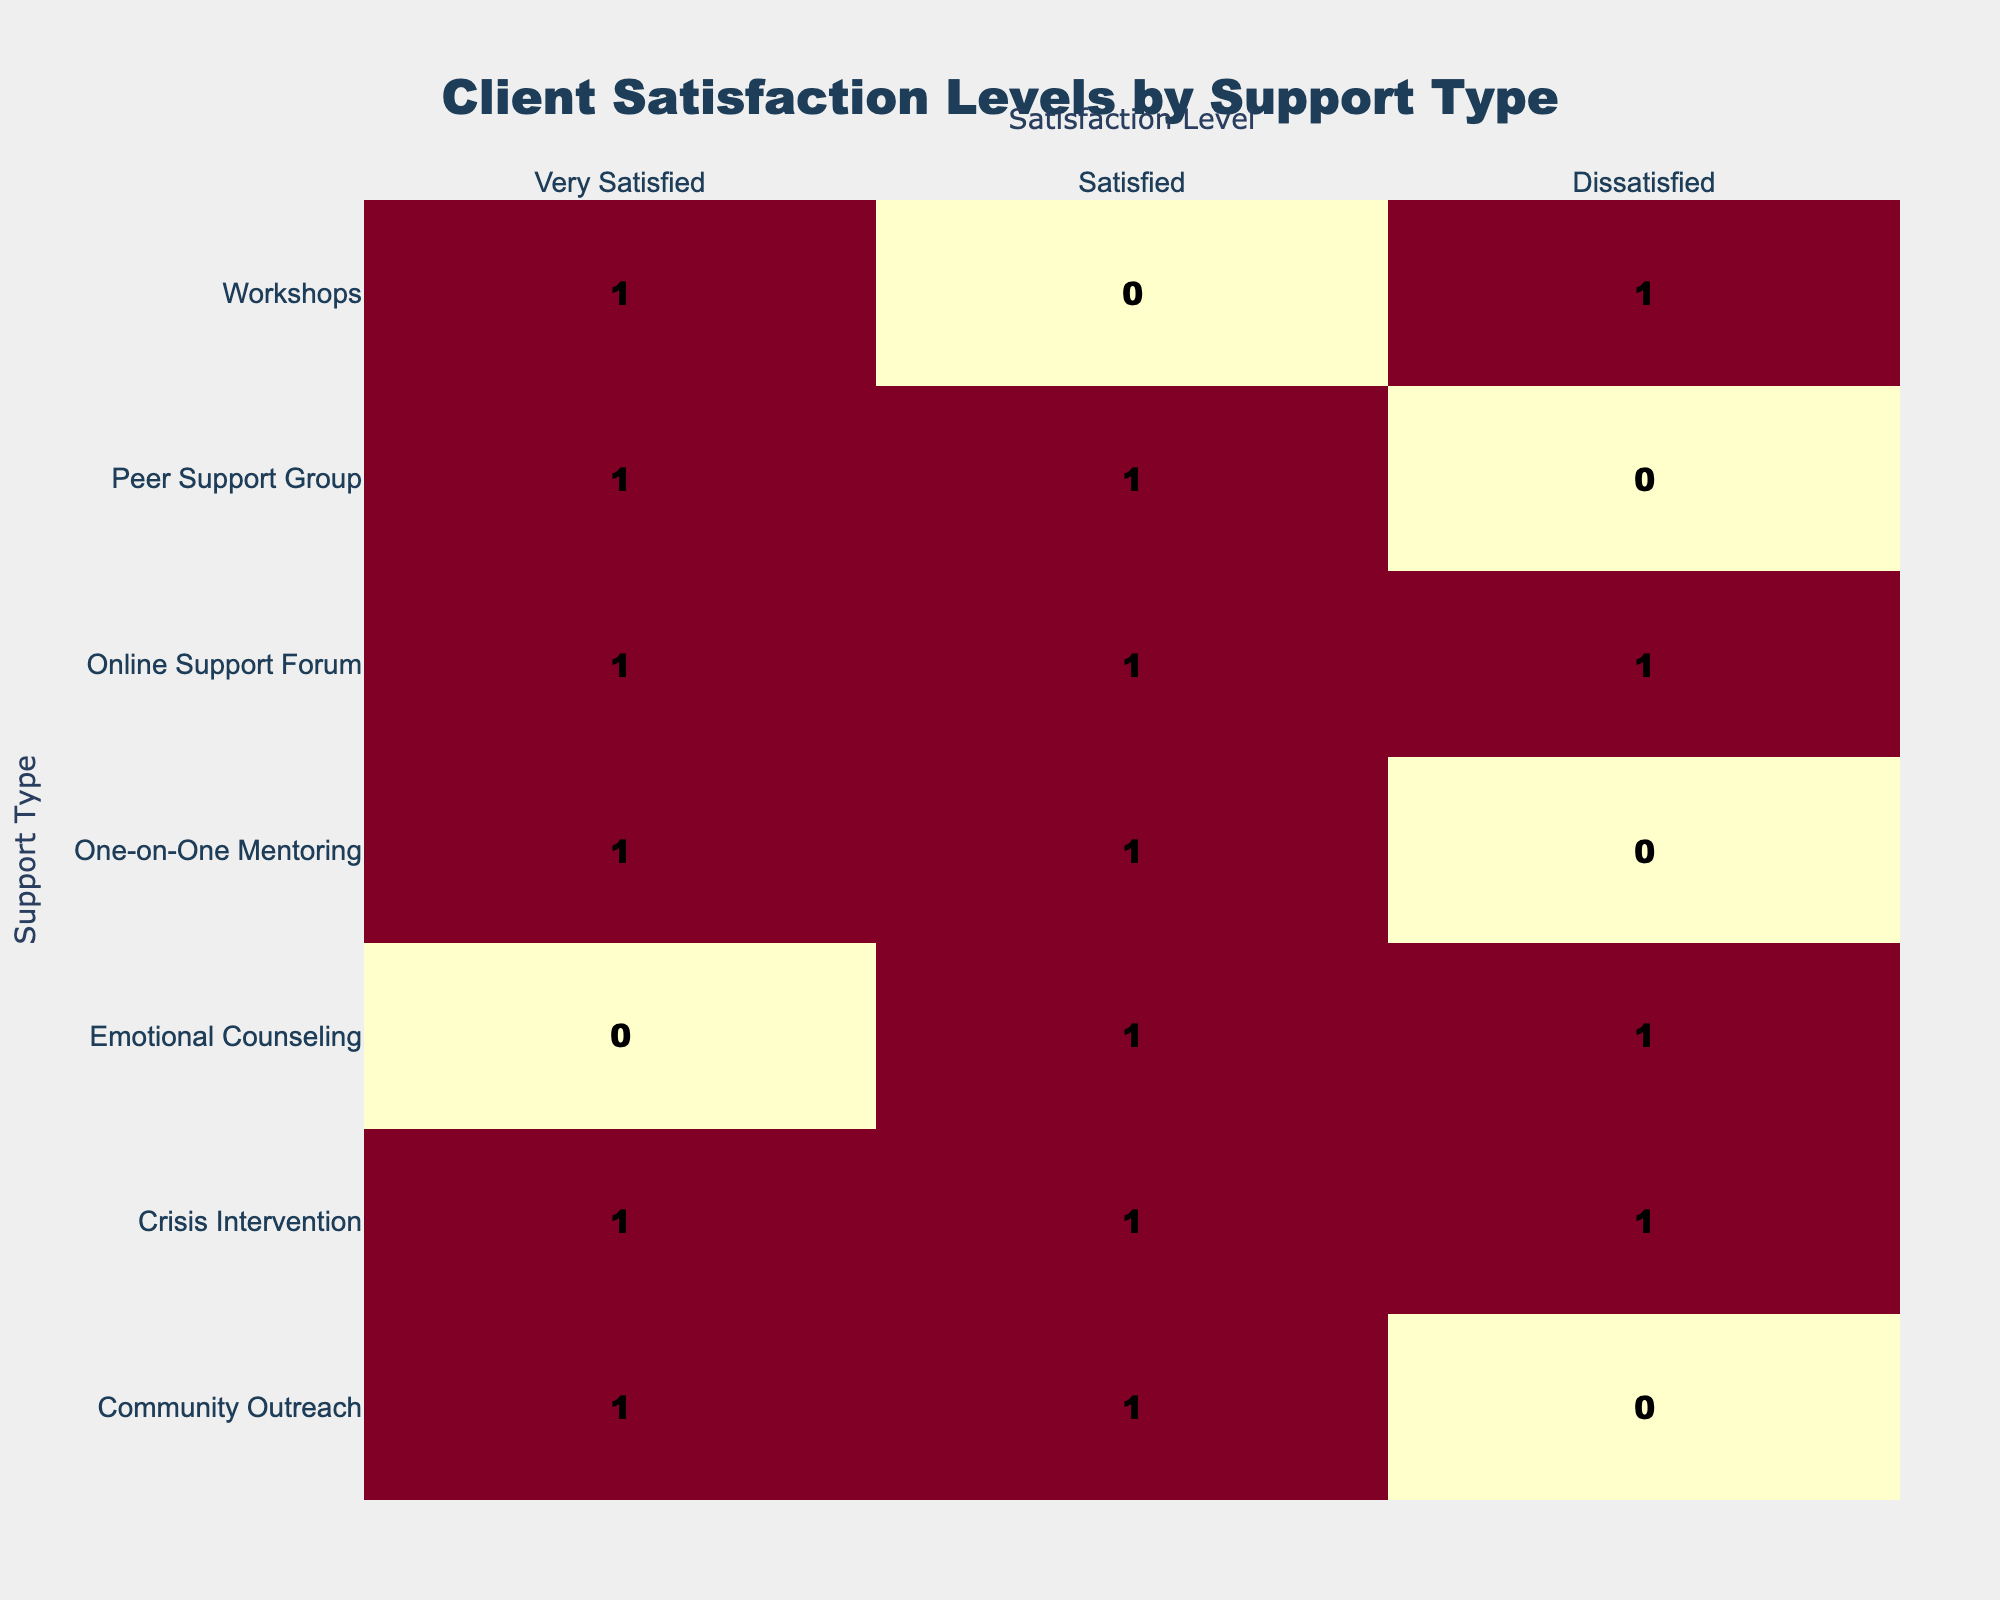What is the total number of clients who reported being Very Satisfied? From the table, we count the occurrences in the "Very Satisfied" column. There are 4 counts: Peer Support Group (1), Crisis Intervention (1), Workshops (1), and Community Outreach (1), adding up to 4 clients in total.
Answer: 4 How many clients reported being Dissatisfied after receiving Workshops? Looking at the "Dissatisfied" row for Workshops in the table shows 1 client. Therefore, the answer is directly found from this specific entry.
Answer: 1 Is the number of clients who are Satisfied higher than those who are Dissatisfied for Crisis Intervention? For Crisis Intervention, there are 1 client reported as Satisfied and 1 client reported as Dissatisfied. Since they are equal, the answer is no.
Answer: No Which support type received the highest number of clients reporting Satisfied? Counting the "Satisfied" entries in the table shows that Crisis Intervention and One-on-One Mentoring both received 1 client; however, Peer Support Group and Online Support Forum accounted for 1 each as well. None of the support types exceeds 1 in this category.
Answer: Peer Support Group, Online Support Forum, Crisis Intervention and One-on-One Mentoring What is the difference between the total number of Very Satisfied clients and those who are Dissatisfied? There are 4 clients who reported being Very Satisfied, as previously calculated, and 3 clients who reported being Dissatisfied. The difference is calculated as 4 (Very Satisfied) - 3 (Dissatisfied) = 1.
Answer: 1 Is it true that more clients attended Peer Support Group than One-on-One Mentoring? Peer Support Group has 2 reports, while One-on-One Mentoring has 2 reports as well (1 Satisfied and 1 Very Satisfied), indicating they have the same number of clients. Therefore, the statement is false.
Answer: No What percentage of clients who received Emotional Counseling reported being Satisfied? For Emotional Counseling, there are 1 client reported as Satisfied and 1 client as Dissatisfied, making a total of 2 clients. The percentage of clients being Satisfied is calculated as (1/2)*100 = 50%.
Answer: 50% How many more clients were Very Satisfied compared to those who were Dissatisfied for Community Outreach? In the case of Community Outreach, there are 1 client reported as Very Satisfied and none reported as Dissatisfied. The difference is calculated as 1 (Very Satisfied) - 0 (Dissatisfied) = 1.
Answer: 1 What support type has the highest total number of clients across all satisfaction levels? By adding up the total clients for each support type, we find: Emotional Counseling (2), Peer Support Group (2), Crisis Intervention (3), One-on-One Mentoring (2), Workshops (2), Online Support Forum (3), and Community Outreach (2). The support types with the highest total clients are Crisis Intervention and Online Support Forum, each with 3 clients.
Answer: Crisis Intervention and Online Support Forum 